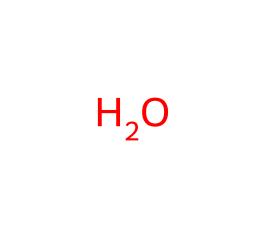What is the primary component of oobleck? Oobleck is primarily made of cornstarch and water. The SMILES representation shows a single oxygen atom, indicating the water component as H2O (from H2O that typically accompanies starch). The lack of carbon in the representation suggests it's a simplistic view, focusing on the most significant chemical interaction (water) necessary to create oobleck.
Answer: water How many types of components are in oobleck? Oobleck is made of two components: cornstarch and water. The SMILES representation only depicts water, which is one of the two components in the mixture, indicating that cornstarch is not represented but is essential for the creation of oobleck.
Answer: two What type of mixture is oobleck? Oobleck is a non-Newtonian fluid made by mixing cornstarch and water. This means its viscosity changes under stress, and while the SMILES representation doesn't depict cornstarch directly, it is part of the definition of how oobleck behaves.
Answer: non-Newtonian What property does oobleck display under pressure? Oobleck exhibits shear-thickening behavior when pressure is applied. The combination of cornstarch with water creates a dense suspension that resists flow, thus becoming solid-like under stress, which reflects a key characteristic of non-Newtonian fluids.
Answer: shear-thickening Can oobleck be formed from the representation? No, the SMILES representation only shows a water molecule (oxygen), so it cannot give a full picture of oobleck's chemical makeup without representing cornstarch. Oobleck requires both water and cornstarch to exhibit its unique properties.
Answer: no 